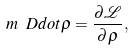Convert formula to latex. <formula><loc_0><loc_0><loc_500><loc_500>m \ D d o t { \rho } = \frac { \partial \mathcal { L } } { \partial \rho } ,</formula> 